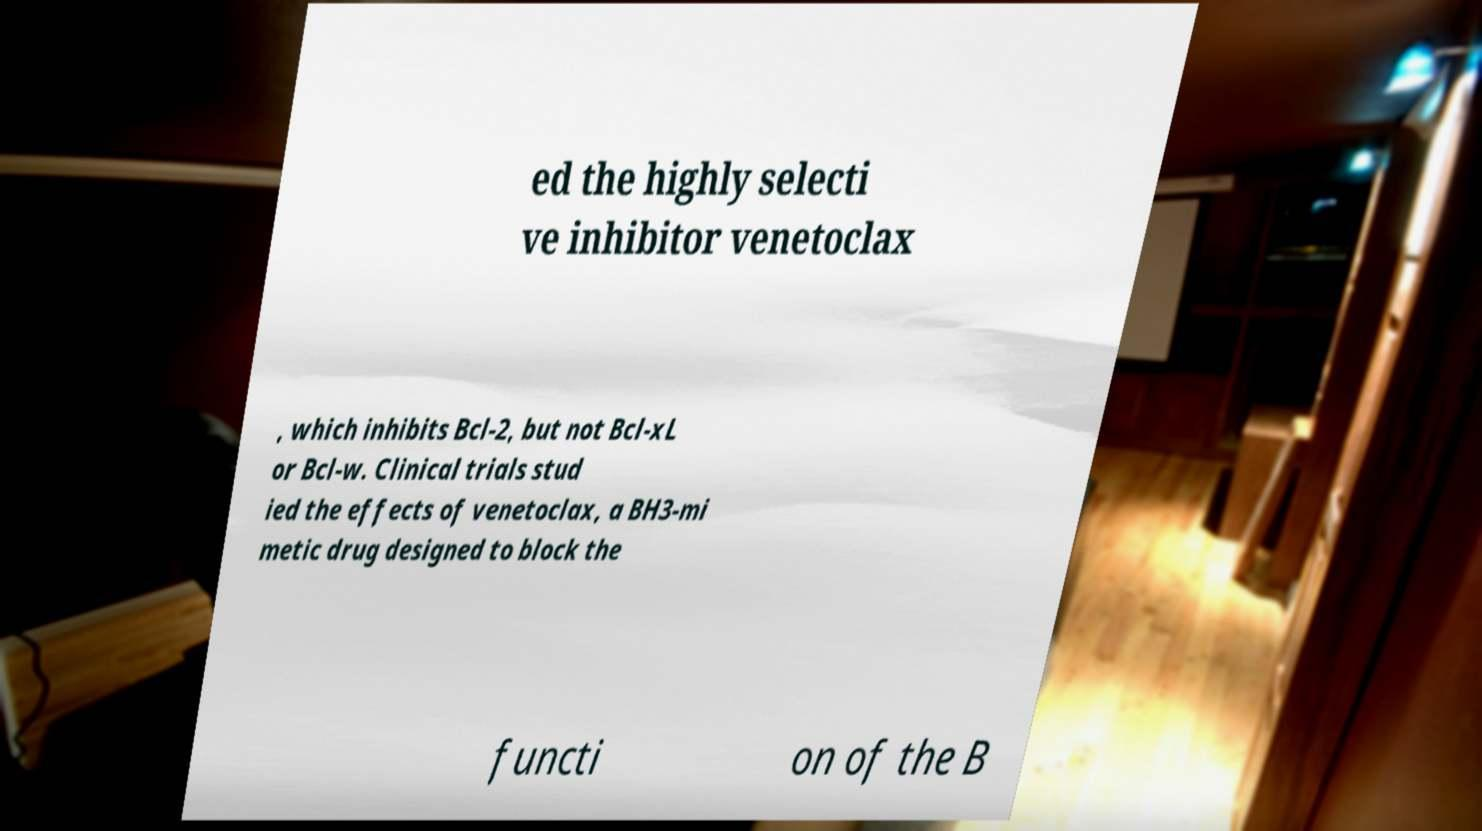Could you assist in decoding the text presented in this image and type it out clearly? ed the highly selecti ve inhibitor venetoclax , which inhibits Bcl-2, but not Bcl-xL or Bcl-w. Clinical trials stud ied the effects of venetoclax, a BH3-mi metic drug designed to block the functi on of the B 